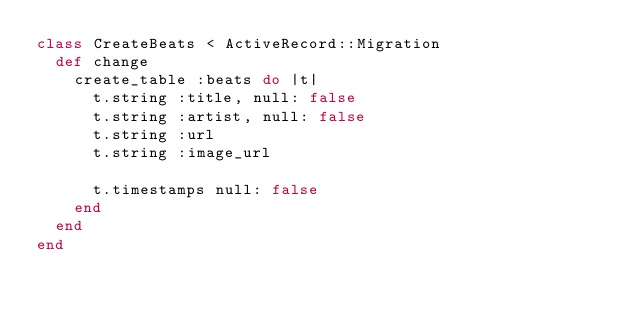Convert code to text. <code><loc_0><loc_0><loc_500><loc_500><_Ruby_>class CreateBeats < ActiveRecord::Migration
  def change
    create_table :beats do |t|
      t.string :title, null: false
      t.string :artist, null: false
      t.string :url
      t.string :image_url

      t.timestamps null: false
    end
  end
end
</code> 